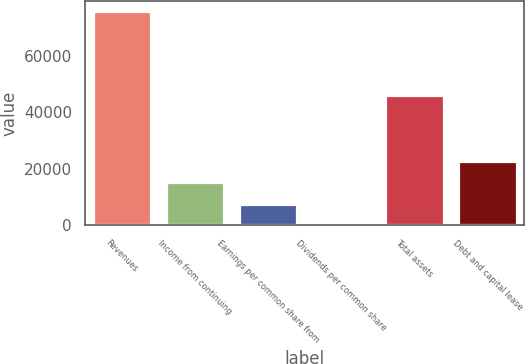Convert chart. <chart><loc_0><loc_0><loc_500><loc_500><bar_chart><fcel>Revenues<fcel>Income from continuing<fcel>Earnings per common share from<fcel>Dividends per common share<fcel>Total assets<fcel>Debt and capital lease<nl><fcel>75659<fcel>15133.7<fcel>7568.06<fcel>2.4<fcel>46173<fcel>22699.4<nl></chart> 